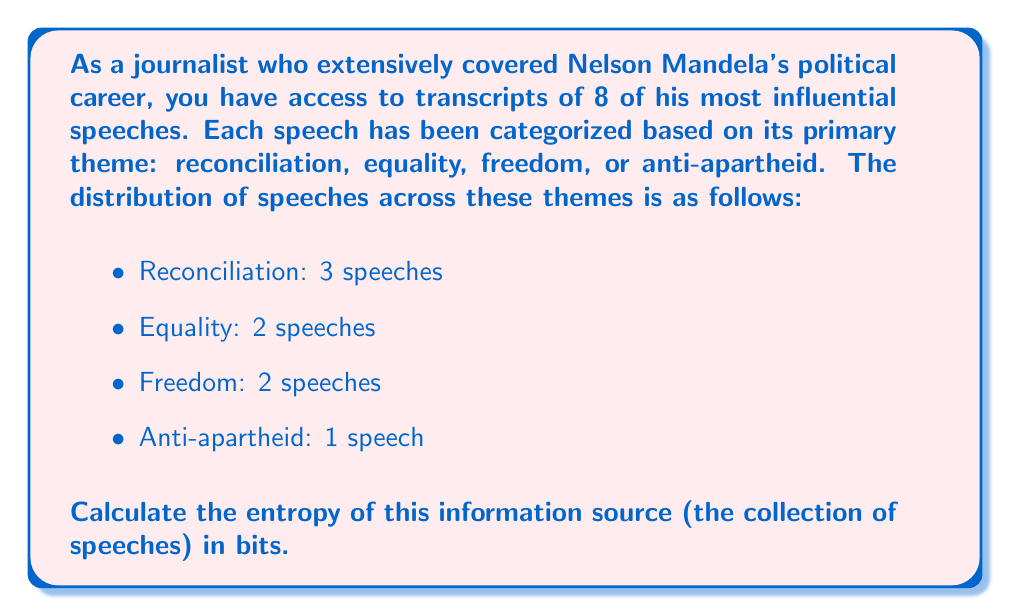Provide a solution to this math problem. To calculate the entropy of this information source, we'll use Shannon's entropy formula:

$$H = -\sum_{i=1}^n p(x_i) \log_2 p(x_i)$$

Where:
- $H$ is the entropy in bits
- $p(x_i)$ is the probability of each outcome
- $n$ is the number of possible outcomes

Step 1: Calculate the probabilities for each theme:
- $p(\text{Reconciliation}) = 3/8 = 0.375$
- $p(\text{Equality}) = 2/8 = 0.25$
- $p(\text{Freedom}) = 2/8 = 0.25$
- $p(\text{Anti-apartheid}) = 1/8 = 0.125$

Step 2: Apply the entropy formula:

$$\begin{align*}
H &= -[p(\text{Reconciliation}) \log_2 p(\text{Reconciliation}) + \\
&\quad p(\text{Equality}) \log_2 p(\text{Equality}) + \\
&\quad p(\text{Freedom}) \log_2 p(\text{Freedom}) + \\
&\quad p(\text{Anti-apartheid}) \log_2 p(\text{Anti-apartheid})]
\end{align*}$$

Step 3: Substitute the values:

$$\begin{align*}
H &= -[0.375 \log_2 0.375 + 0.25 \log_2 0.25 + 0.25 \log_2 0.25 + 0.125 \log_2 0.125] \\
&= -[0.375 \times (-1.415) + 0.25 \times (-2) + 0.25 \times (-2) + 0.125 \times (-3)] \\
&= -[-0.530625 - 0.5 - 0.5 - 0.375] \\
&= 1.905625
\end{align*}$$

Therefore, the entropy of this information source is approximately 1.91 bits.
Answer: 1.91 bits 